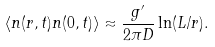Convert formula to latex. <formula><loc_0><loc_0><loc_500><loc_500>\langle n ( { r } , t ) n ( { 0 } , t ) \rangle \approx \frac { g ^ { \prime } } { 2 \pi D } \ln ( L / r ) .</formula> 